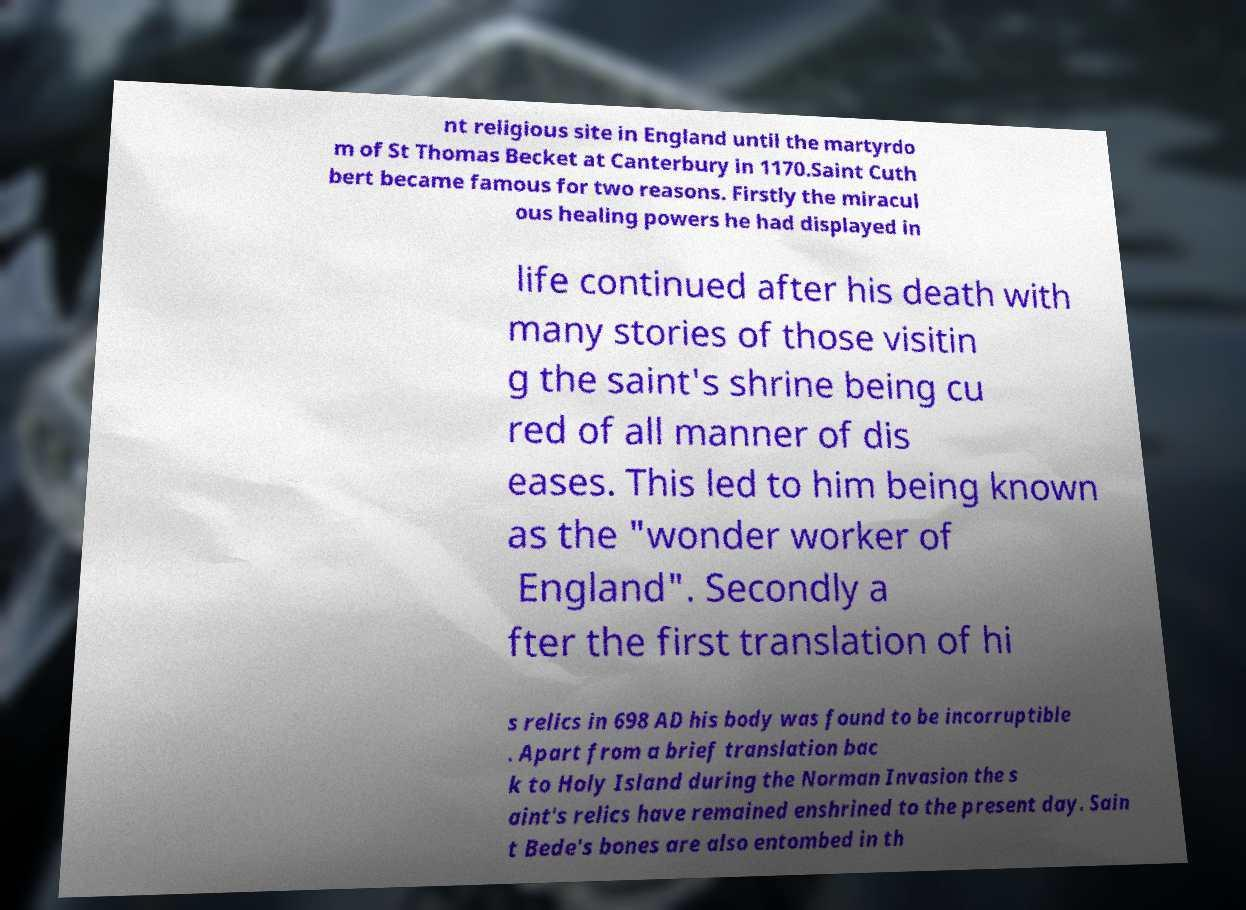Can you accurately transcribe the text from the provided image for me? nt religious site in England until the martyrdo m of St Thomas Becket at Canterbury in 1170.Saint Cuth bert became famous for two reasons. Firstly the miracul ous healing powers he had displayed in life continued after his death with many stories of those visitin g the saint's shrine being cu red of all manner of dis eases. This led to him being known as the "wonder worker of England". Secondly a fter the first translation of hi s relics in 698 AD his body was found to be incorruptible . Apart from a brief translation bac k to Holy Island during the Norman Invasion the s aint's relics have remained enshrined to the present day. Sain t Bede's bones are also entombed in th 